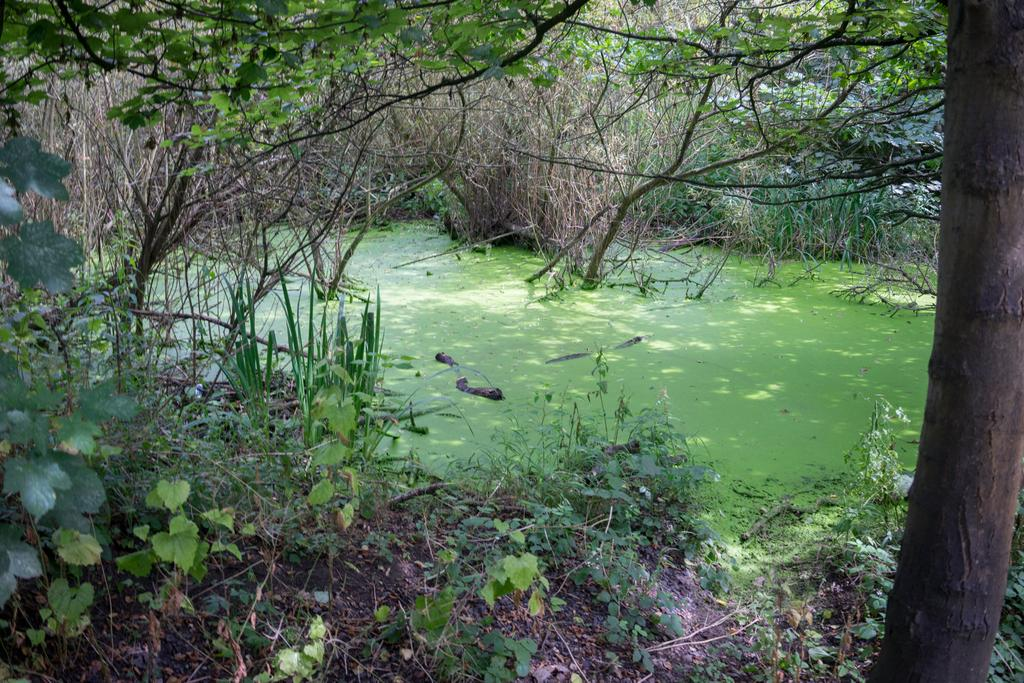What type of vegetation can be seen in the image? There are plants and trees in the image. Can you describe the water in the image? Algae are present on the water in the image. What type of skirt is the tree wearing in the image? There are no skirts present in the image, as trees are not capable of wearing clothing. 